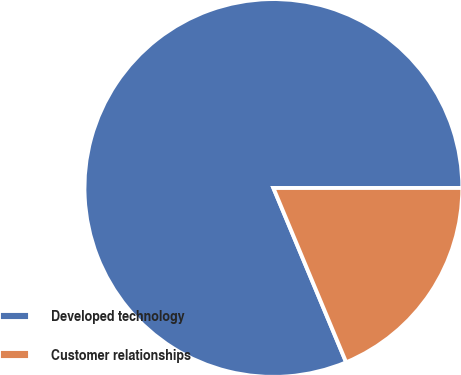Convert chart. <chart><loc_0><loc_0><loc_500><loc_500><pie_chart><fcel>Developed technology<fcel>Customer relationships<nl><fcel>81.29%<fcel>18.71%<nl></chart> 